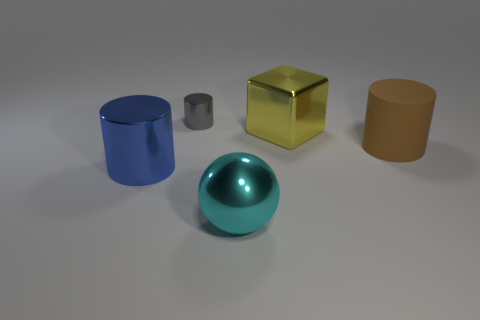Are there an equal number of big brown things and big cyan rubber spheres?
Your answer should be compact. No. Is there another cyan shiny thing that has the same shape as the small metallic thing?
Provide a short and direct response. No. There is a cylinder that is on the right side of the big cyan metal ball; is it the same size as the cylinder that is behind the yellow object?
Make the answer very short. No. Is the number of large yellow objects on the left side of the large metallic cylinder less than the number of large yellow metallic objects that are to the left of the metallic sphere?
Offer a very short reply. No. The thing in front of the blue thing is what color?
Your answer should be very brief. Cyan. Do the tiny cylinder and the sphere have the same color?
Your response must be concise. No. There is a ball in front of the metal cylinder that is behind the block; what number of blue shiny things are to the right of it?
Keep it short and to the point. 0. The cyan metal sphere has what size?
Offer a very short reply. Large. What is the material of the yellow thing that is the same size as the brown thing?
Make the answer very short. Metal. How many small gray objects are on the left side of the blue metal object?
Give a very brief answer. 0. 